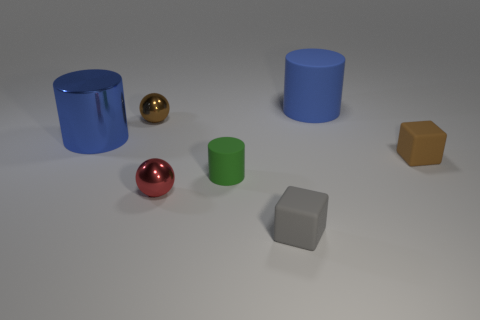Add 1 large purple spheres. How many objects exist? 8 Subtract all blocks. How many objects are left? 5 Subtract all tiny green cylinders. Subtract all tiny spheres. How many objects are left? 4 Add 6 small gray rubber cubes. How many small gray rubber cubes are left? 7 Add 2 big blue objects. How many big blue objects exist? 4 Subtract 0 cyan blocks. How many objects are left? 7 